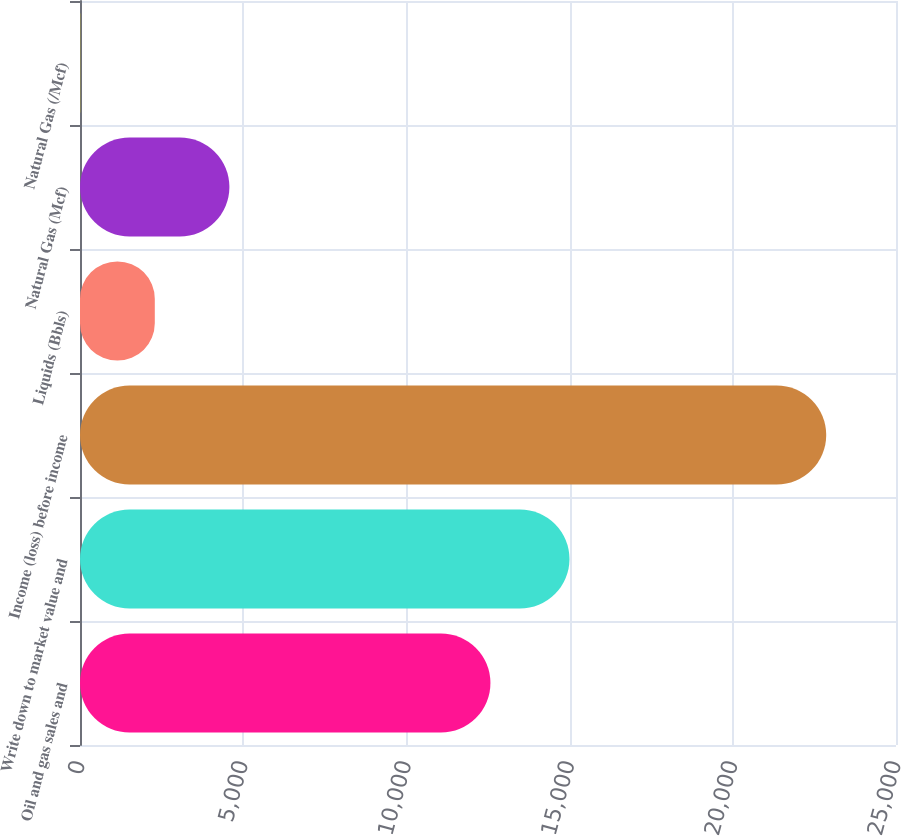<chart> <loc_0><loc_0><loc_500><loc_500><bar_chart><fcel>Oil and gas sales and<fcel>Write down to market value and<fcel>Income (loss) before income<fcel>Liquids (Bbls)<fcel>Natural Gas (Mcf)<fcel>Natural Gas (/Mcf)<nl><fcel>12575<fcel>14996<fcel>22862<fcel>2291.63<fcel>4577.23<fcel>6.03<nl></chart> 